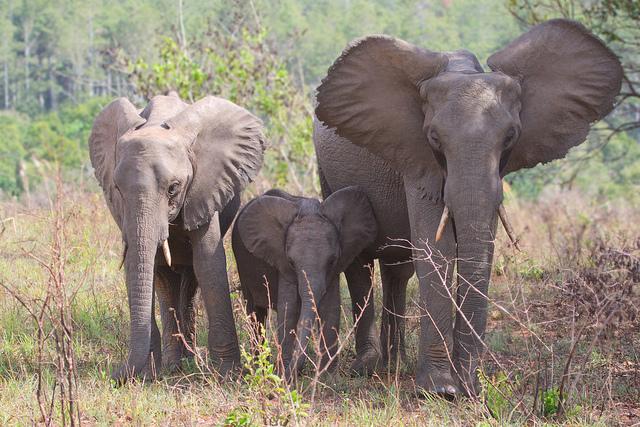How many elephants?
Answer briefly. 3. Do the elephant have big ears?
Answer briefly. Yes. Which animals are they?
Answer briefly. Elephants. 